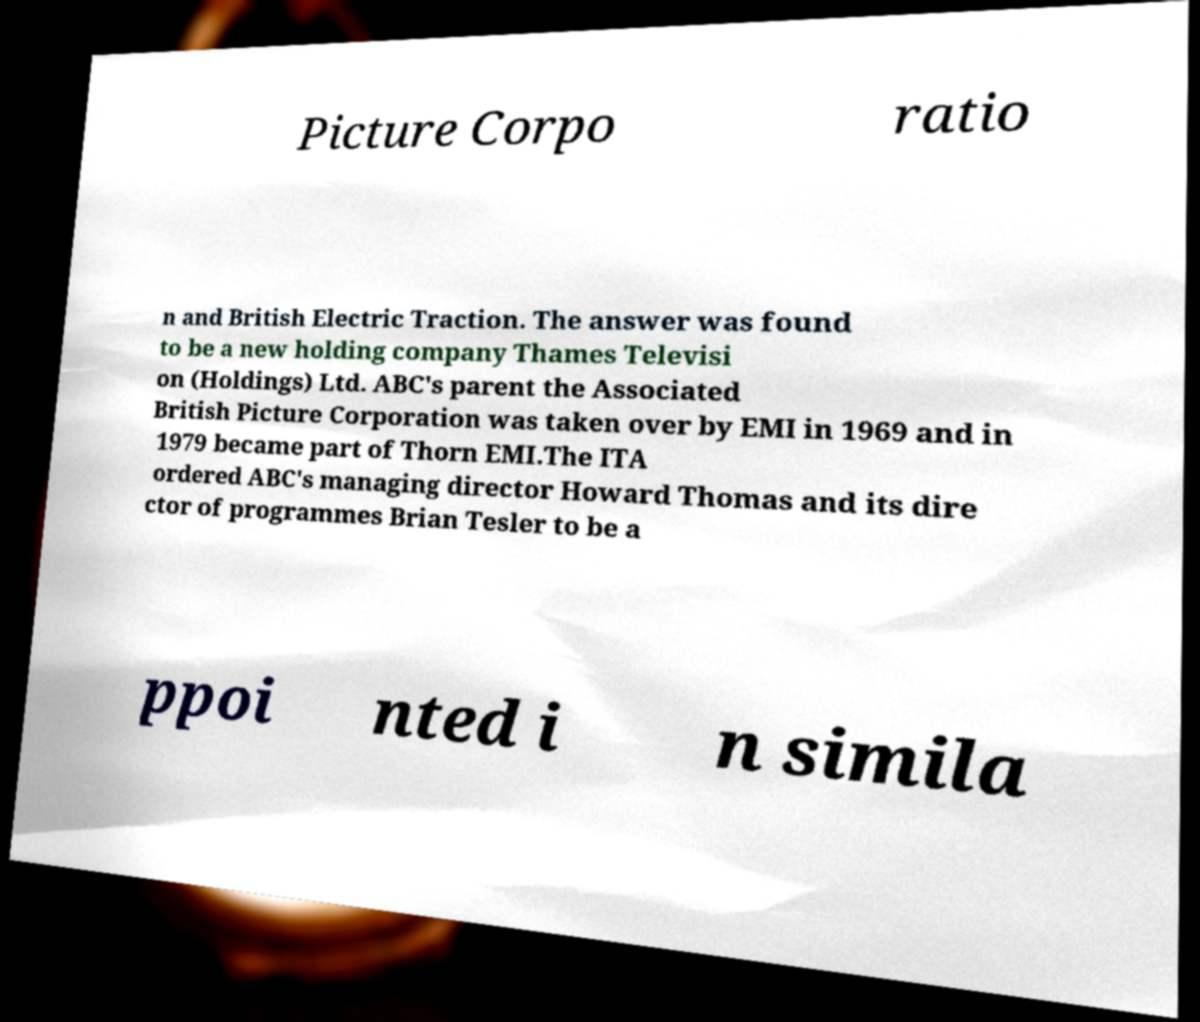Please identify and transcribe the text found in this image. Picture Corpo ratio n and British Electric Traction. The answer was found to be a new holding company Thames Televisi on (Holdings) Ltd. ABC's parent the Associated British Picture Corporation was taken over by EMI in 1969 and in 1979 became part of Thorn EMI.The ITA ordered ABC's managing director Howard Thomas and its dire ctor of programmes Brian Tesler to be a ppoi nted i n simila 